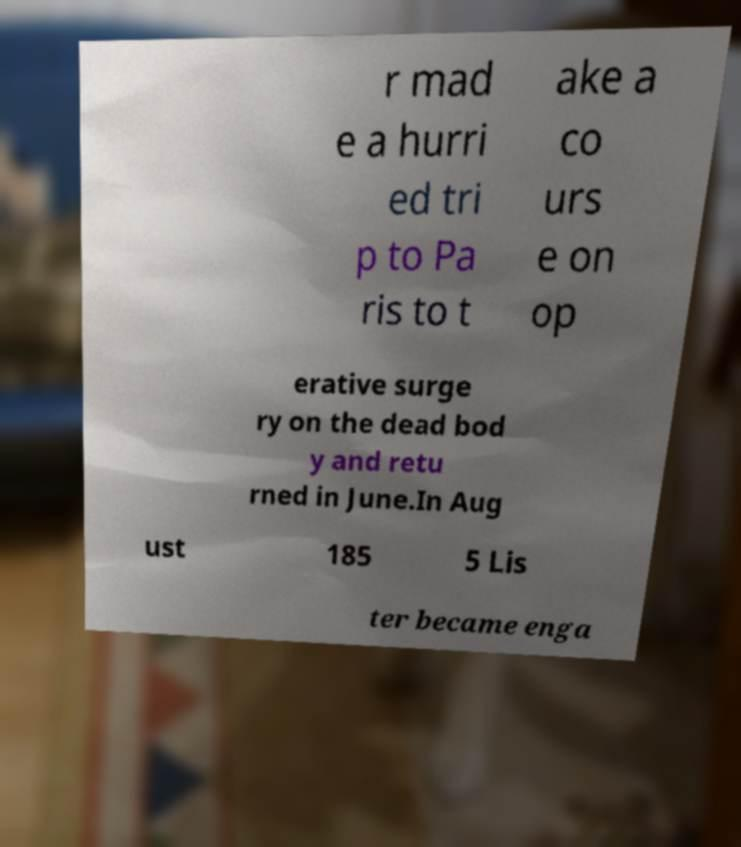Could you extract and type out the text from this image? r mad e a hurri ed tri p to Pa ris to t ake a co urs e on op erative surge ry on the dead bod y and retu rned in June.In Aug ust 185 5 Lis ter became enga 